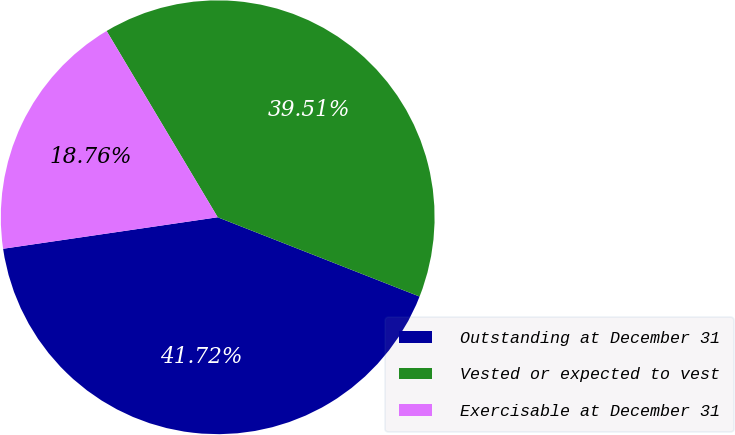Convert chart to OTSL. <chart><loc_0><loc_0><loc_500><loc_500><pie_chart><fcel>Outstanding at December 31<fcel>Vested or expected to vest<fcel>Exercisable at December 31<nl><fcel>41.72%<fcel>39.51%<fcel>18.76%<nl></chart> 